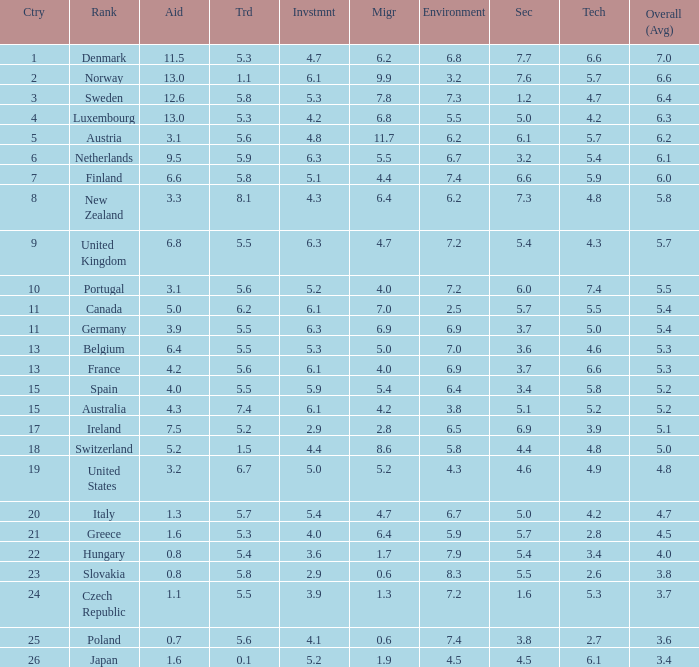What country has a 5.5 mark for security? Slovakia. 